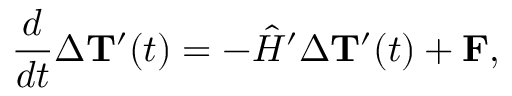<formula> <loc_0><loc_0><loc_500><loc_500>\frac { d } { d t } \Delta { { T } ^ { \prime } } ( t ) = - { \hat { H } ^ { \prime } } \Delta { { T } ^ { \prime } } ( t ) + { F } ,</formula> 